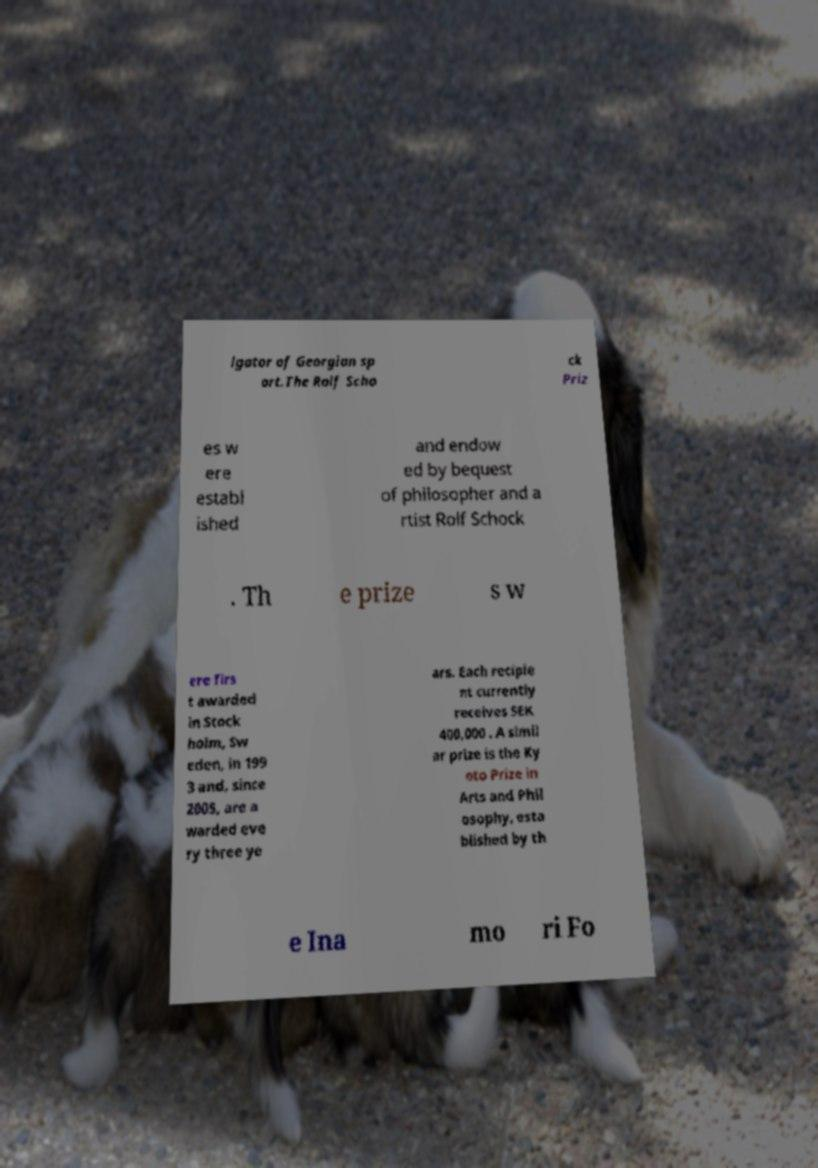For documentation purposes, I need the text within this image transcribed. Could you provide that? lgator of Georgian sp ort.The Rolf Scho ck Priz es w ere establ ished and endow ed by bequest of philosopher and a rtist Rolf Schock . Th e prize s w ere firs t awarded in Stock holm, Sw eden, in 199 3 and, since 2005, are a warded eve ry three ye ars. Each recipie nt currently receives SEK 400,000 . A simil ar prize is the Ky oto Prize in Arts and Phil osophy, esta blished by th e Ina mo ri Fo 